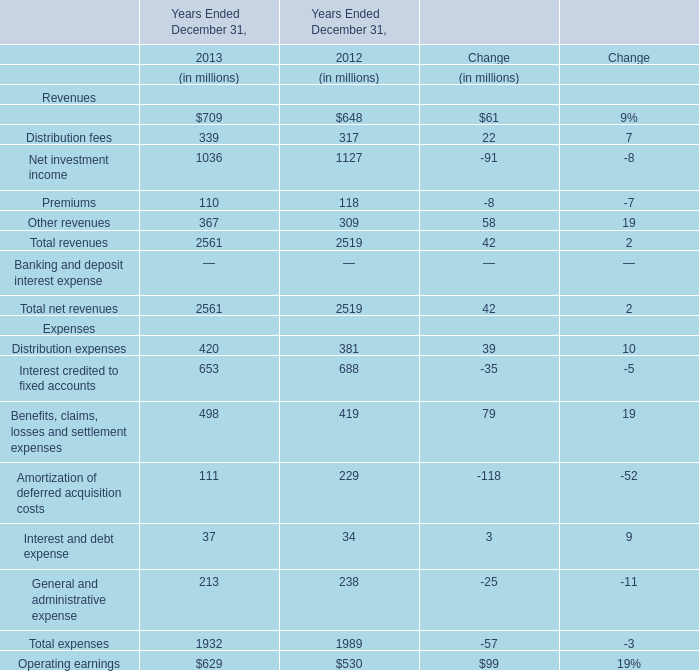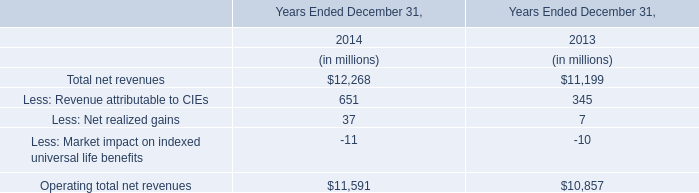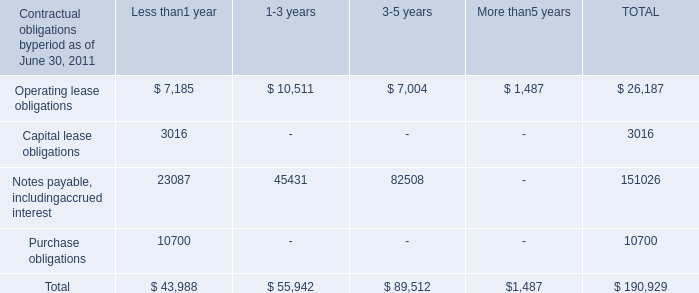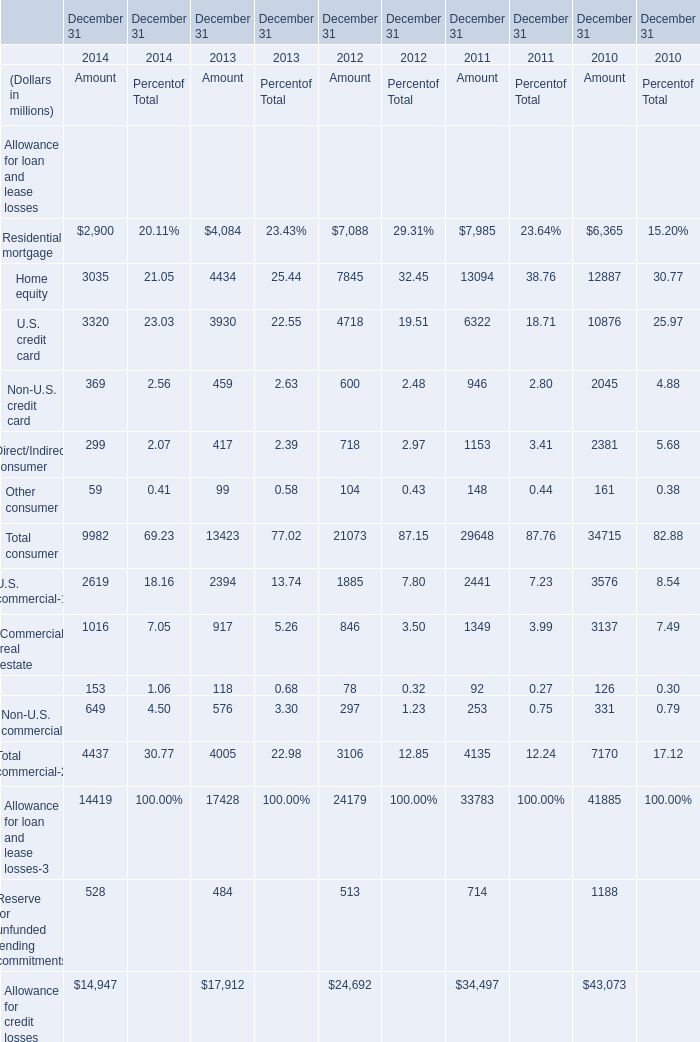What is the growing rate of Less: Revenue attributable to CIEs in the year with the most Management and financial advice fees for Revenues? 
Computations: ((651 - 345) / 345)
Answer: 0.88696. 